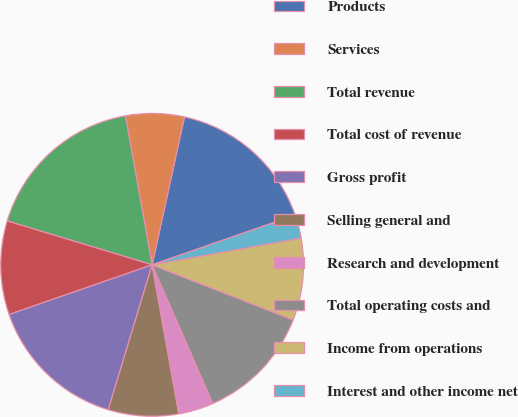Convert chart. <chart><loc_0><loc_0><loc_500><loc_500><pie_chart><fcel>Products<fcel>Services<fcel>Total revenue<fcel>Total cost of revenue<fcel>Gross profit<fcel>Selling general and<fcel>Research and development<fcel>Total operating costs and<fcel>Income from operations<fcel>Interest and other income net<nl><fcel>16.25%<fcel>6.25%<fcel>17.5%<fcel>10.0%<fcel>15.0%<fcel>7.5%<fcel>3.75%<fcel>12.5%<fcel>8.75%<fcel>2.5%<nl></chart> 